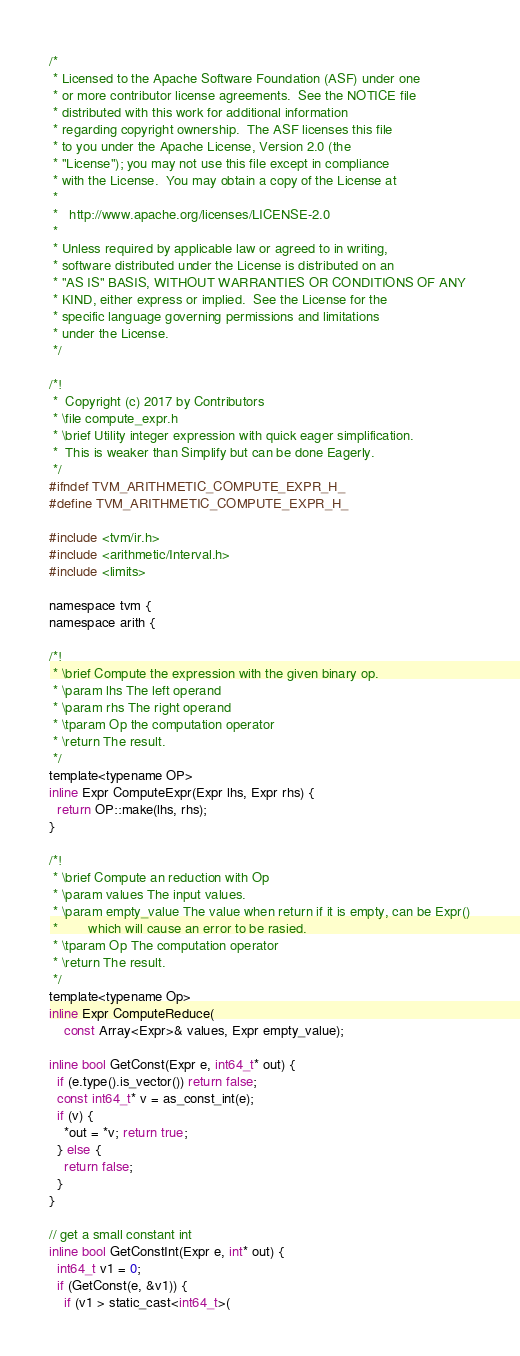Convert code to text. <code><loc_0><loc_0><loc_500><loc_500><_C_>/*
 * Licensed to the Apache Software Foundation (ASF) under one
 * or more contributor license agreements.  See the NOTICE file
 * distributed with this work for additional information
 * regarding copyright ownership.  The ASF licenses this file
 * to you under the Apache License, Version 2.0 (the
 * "License"); you may not use this file except in compliance
 * with the License.  You may obtain a copy of the License at
 * 
 *   http://www.apache.org/licenses/LICENSE-2.0
 * 
 * Unless required by applicable law or agreed to in writing,
 * software distributed under the License is distributed on an
 * "AS IS" BASIS, WITHOUT WARRANTIES OR CONDITIONS OF ANY
 * KIND, either express or implied.  See the License for the
 * specific language governing permissions and limitations
 * under the License.
 */

/*!
 *  Copyright (c) 2017 by Contributors
 * \file compute_expr.h
 * \brief Utility integer expression with quick eager simplification.
 *  This is weaker than Simplify but can be done Eagerly.
 */
#ifndef TVM_ARITHMETIC_COMPUTE_EXPR_H_
#define TVM_ARITHMETIC_COMPUTE_EXPR_H_

#include <tvm/ir.h>
#include <arithmetic/Interval.h>
#include <limits>

namespace tvm {
namespace arith {

/*!
 * \brief Compute the expression with the given binary op.
 * \param lhs The left operand
 * \param rhs The right operand
 * \tparam Op the computation operator
 * \return The result.
 */
template<typename OP>
inline Expr ComputeExpr(Expr lhs, Expr rhs) {
  return OP::make(lhs, rhs);
}

/*!
 * \brief Compute an reduction with Op
 * \param values The input values.
 * \param empty_value The value when return if it is empty, can be Expr()
 *        which will cause an error to be rasied.
 * \tparam Op The computation operator
 * \return The result.
 */
template<typename Op>
inline Expr ComputeReduce(
    const Array<Expr>& values, Expr empty_value);

inline bool GetConst(Expr e, int64_t* out) {
  if (e.type().is_vector()) return false;
  const int64_t* v = as_const_int(e);
  if (v) {
    *out = *v; return true;
  } else {
    return false;
  }
}

// get a small constant int
inline bool GetConstInt(Expr e, int* out) {
  int64_t v1 = 0;
  if (GetConst(e, &v1)) {
    if (v1 > static_cast<int64_t>(</code> 